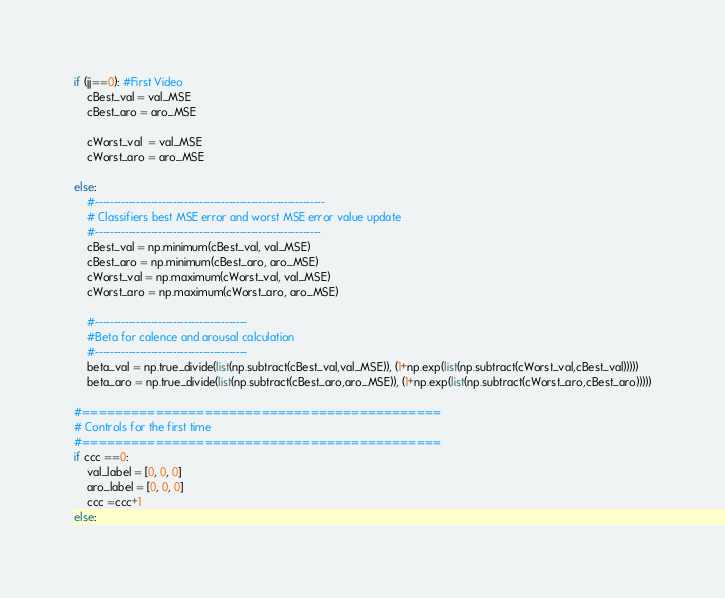Convert code to text. <code><loc_0><loc_0><loc_500><loc_500><_Python_>
if (jj==0): #First Video
    cBest_val = val_MSE
    cBest_aro = aro_MSE

    cWorst_val  = val_MSE
    cWorst_aro = aro_MSE

else:
    #--------------------------------------------------------------
    # Classifiers best MSE error and worst MSE error value update
    #-------------------------------------------------------------
    cBest_val = np.minimum(cBest_val, val_MSE)
    cBest_aro = np.minimum(cBest_aro, aro_MSE)
    cWorst_val = np.maximum(cWorst_val, val_MSE)
    cWorst_aro = np.maximum(cWorst_aro, aro_MSE)

    #-----------------------------------------
    #Beta for calence and arousal calculation
    #-----------------------------------------              
    beta_val = np.true_divide(list(np.subtract(cBest_val,val_MSE)), (1+np.exp(list(np.subtract(cWorst_val,cBest_val)))))
    beta_aro = np.true_divide(list(np.subtract(cBest_aro,aro_MSE)), (1+np.exp(list(np.subtract(cWorst_aro,cBest_aro)))))

#============================================
# Controls for the first time
#============================================
if ccc ==0:
    val_label = [0, 0, 0]
    aro_label = [0, 0, 0] 
    ccc =ccc+1
else:</code> 